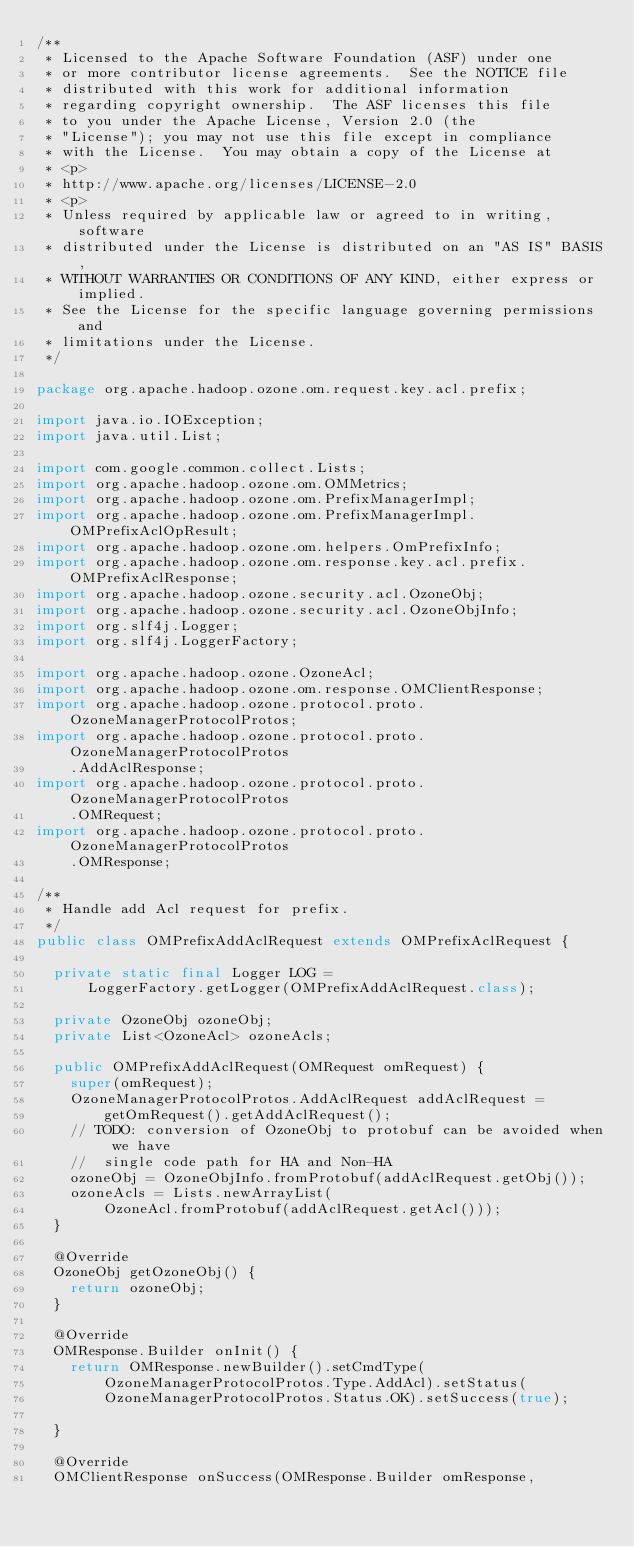Convert code to text. <code><loc_0><loc_0><loc_500><loc_500><_Java_>/**
 * Licensed to the Apache Software Foundation (ASF) under one
 * or more contributor license agreements.  See the NOTICE file
 * distributed with this work for additional information
 * regarding copyright ownership.  The ASF licenses this file
 * to you under the Apache License, Version 2.0 (the
 * "License"); you may not use this file except in compliance
 * with the License.  You may obtain a copy of the License at
 * <p>
 * http://www.apache.org/licenses/LICENSE-2.0
 * <p>
 * Unless required by applicable law or agreed to in writing, software
 * distributed under the License is distributed on an "AS IS" BASIS,
 * WITHOUT WARRANTIES OR CONDITIONS OF ANY KIND, either express or implied.
 * See the License for the specific language governing permissions and
 * limitations under the License.
 */

package org.apache.hadoop.ozone.om.request.key.acl.prefix;

import java.io.IOException;
import java.util.List;

import com.google.common.collect.Lists;
import org.apache.hadoop.ozone.om.OMMetrics;
import org.apache.hadoop.ozone.om.PrefixManagerImpl;
import org.apache.hadoop.ozone.om.PrefixManagerImpl.OMPrefixAclOpResult;
import org.apache.hadoop.ozone.om.helpers.OmPrefixInfo;
import org.apache.hadoop.ozone.om.response.key.acl.prefix.OMPrefixAclResponse;
import org.apache.hadoop.ozone.security.acl.OzoneObj;
import org.apache.hadoop.ozone.security.acl.OzoneObjInfo;
import org.slf4j.Logger;
import org.slf4j.LoggerFactory;

import org.apache.hadoop.ozone.OzoneAcl;
import org.apache.hadoop.ozone.om.response.OMClientResponse;
import org.apache.hadoop.ozone.protocol.proto.OzoneManagerProtocolProtos;
import org.apache.hadoop.ozone.protocol.proto.OzoneManagerProtocolProtos
    .AddAclResponse;
import org.apache.hadoop.ozone.protocol.proto.OzoneManagerProtocolProtos
    .OMRequest;
import org.apache.hadoop.ozone.protocol.proto.OzoneManagerProtocolProtos
    .OMResponse;

/**
 * Handle add Acl request for prefix.
 */
public class OMPrefixAddAclRequest extends OMPrefixAclRequest {

  private static final Logger LOG =
      LoggerFactory.getLogger(OMPrefixAddAclRequest.class);

  private OzoneObj ozoneObj;
  private List<OzoneAcl> ozoneAcls;

  public OMPrefixAddAclRequest(OMRequest omRequest) {
    super(omRequest);
    OzoneManagerProtocolProtos.AddAclRequest addAclRequest =
        getOmRequest().getAddAclRequest();
    // TODO: conversion of OzoneObj to protobuf can be avoided when we have
    //  single code path for HA and Non-HA
    ozoneObj = OzoneObjInfo.fromProtobuf(addAclRequest.getObj());
    ozoneAcls = Lists.newArrayList(
        OzoneAcl.fromProtobuf(addAclRequest.getAcl()));
  }

  @Override
  OzoneObj getOzoneObj() {
    return ozoneObj;
  }

  @Override
  OMResponse.Builder onInit() {
    return OMResponse.newBuilder().setCmdType(
        OzoneManagerProtocolProtos.Type.AddAcl).setStatus(
        OzoneManagerProtocolProtos.Status.OK).setSuccess(true);

  }

  @Override
  OMClientResponse onSuccess(OMResponse.Builder omResponse,</code> 